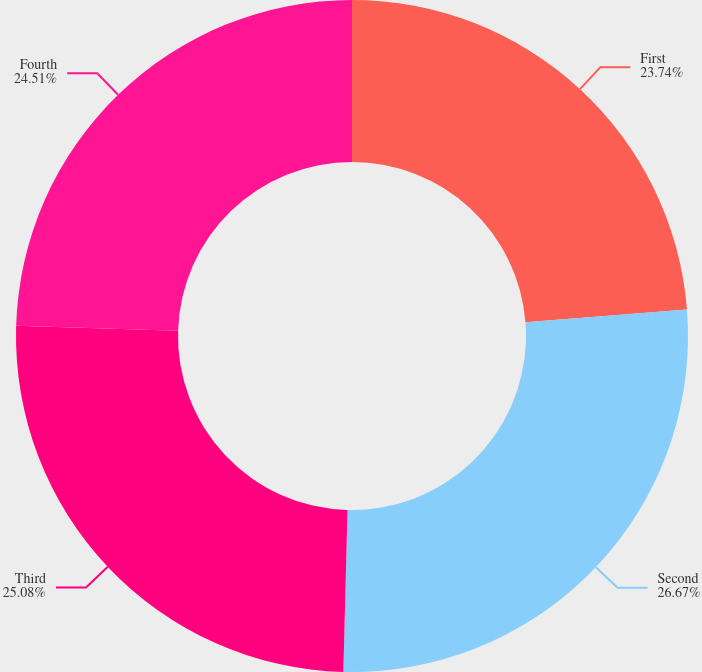<chart> <loc_0><loc_0><loc_500><loc_500><pie_chart><fcel>First<fcel>Second<fcel>Third<fcel>Fourth<nl><fcel>23.74%<fcel>26.67%<fcel>25.08%<fcel>24.51%<nl></chart> 